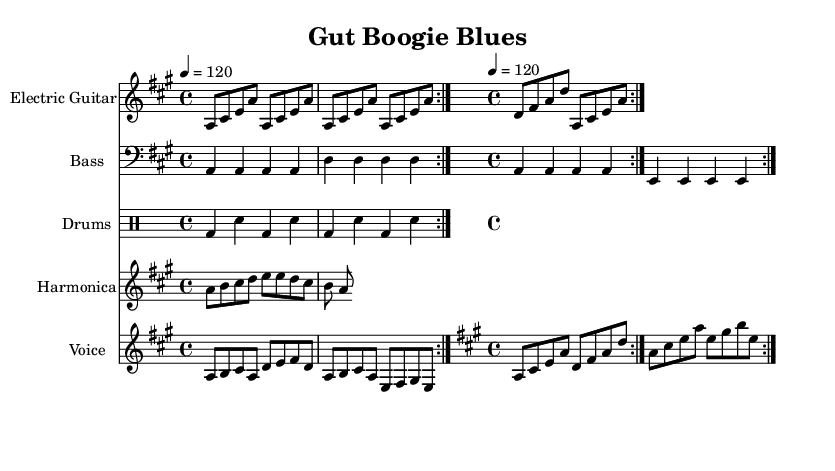What is the title of this piece? The title is indicated at the top of the sheet music in the header section. It reads "Gut Boogie Blues."
Answer: Gut Boogie Blues What is the key signature of this music? The key signature is a major, as indicated by the "key a major" statement in the global section of the code. This means there is three sharps: F sharp, C sharp, and G sharp.
Answer: A major What is the time signature of this music? The time signature is indicated in the global section of the code as "4/4", which implies that there are four beats in each measure and each quarter note gets one beat.
Answer: 4/4 What is the tempo marking for this piece? The tempo is set in the global section where it states "4 = 120." This indicates that there should be 120 beats per minute, where the quarter note equals 120 BPM.
Answer: 120 What instruments are included in this score? The score lists several instruments, which are Electric Guitar, Bass, Drums, Harmonica, and Voice. Each instrument is marked distinctively in the score.
Answer: Electric Guitar, Bass, Drums, Harmonica, Voice How many times is the electric guitar riff repeated in the section provided? The electric guitar part has a specified notation that includes "\repeat volta 2," which indicates that the riff is to be played two times before continuing on.
Answer: 2 What themes do the lyrics of this blues piece convey? The lyrics speak about the journey of food in the digestive system, addressing aspects of chewing and processing food. This is suggested in phrases like "Chew it up and swallow down" and "Digestive blues, from mouth to rear."
Answer: Digestion 